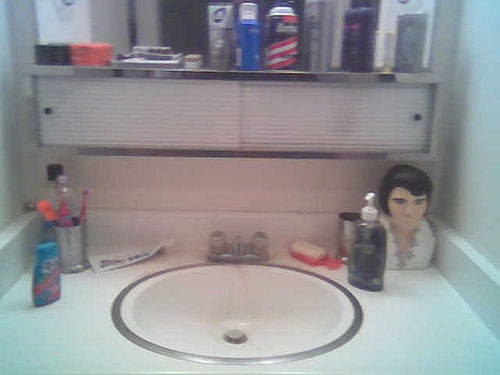Describe the objects in this image and their specific colors. I can see sink in lightblue, darkgray, and lightgray tones, bottle in lightblue, gray, darkgray, black, and lightgray tones, bottle in lightblue, gray, brown, and blue tones, bottle in lightblue, purple, black, and gray tones, and bottle in lightblue, blue, darkgray, and purple tones in this image. 